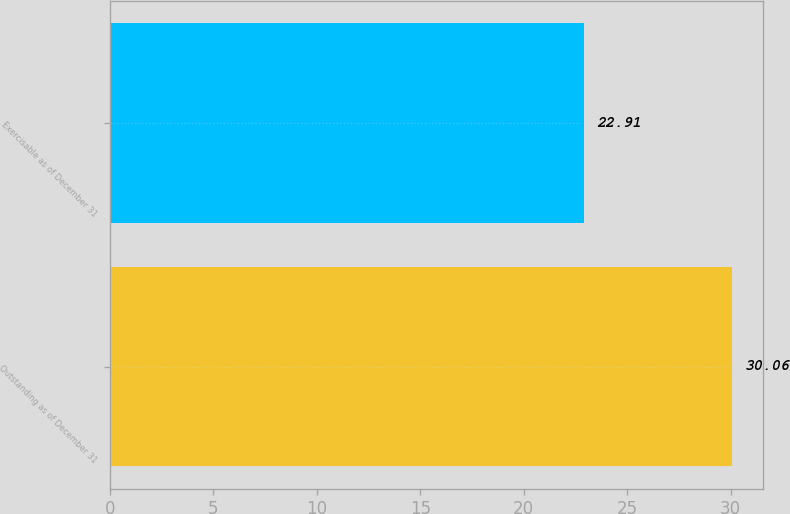<chart> <loc_0><loc_0><loc_500><loc_500><bar_chart><fcel>Outstanding as of December 31<fcel>Exercisable as of December 31<nl><fcel>30.06<fcel>22.91<nl></chart> 